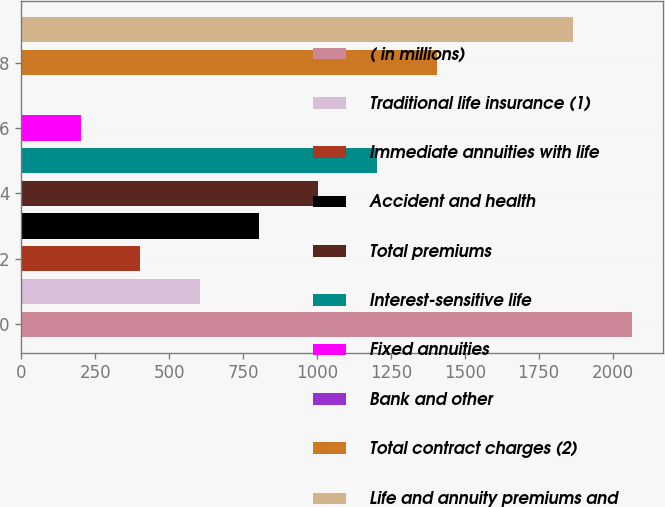<chart> <loc_0><loc_0><loc_500><loc_500><bar_chart><fcel>( in millions)<fcel>Traditional life insurance (1)<fcel>Immediate annuities with life<fcel>Accident and health<fcel>Total premiums<fcel>Interest-sensitive life<fcel>Fixed annuities<fcel>Bank and other<fcel>Total contract charges (2)<fcel>Life and annuity premiums and<nl><fcel>2066.5<fcel>603.5<fcel>403<fcel>804<fcel>1004.5<fcel>1205<fcel>202.5<fcel>2<fcel>1405.5<fcel>1866<nl></chart> 